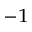Convert formula to latex. <formula><loc_0><loc_0><loc_500><loc_500>^ { - 1 }</formula> 